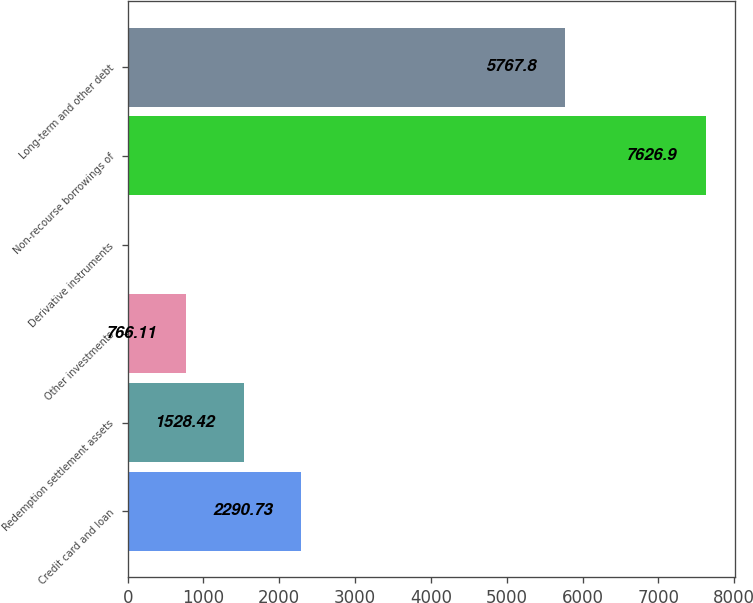Convert chart. <chart><loc_0><loc_0><loc_500><loc_500><bar_chart><fcel>Credit card and loan<fcel>Redemption settlement assets<fcel>Other investments<fcel>Derivative instruments<fcel>Non-recourse borrowings of<fcel>Long-term and other debt<nl><fcel>2290.73<fcel>1528.42<fcel>766.11<fcel>3.8<fcel>7626.9<fcel>5767.8<nl></chart> 